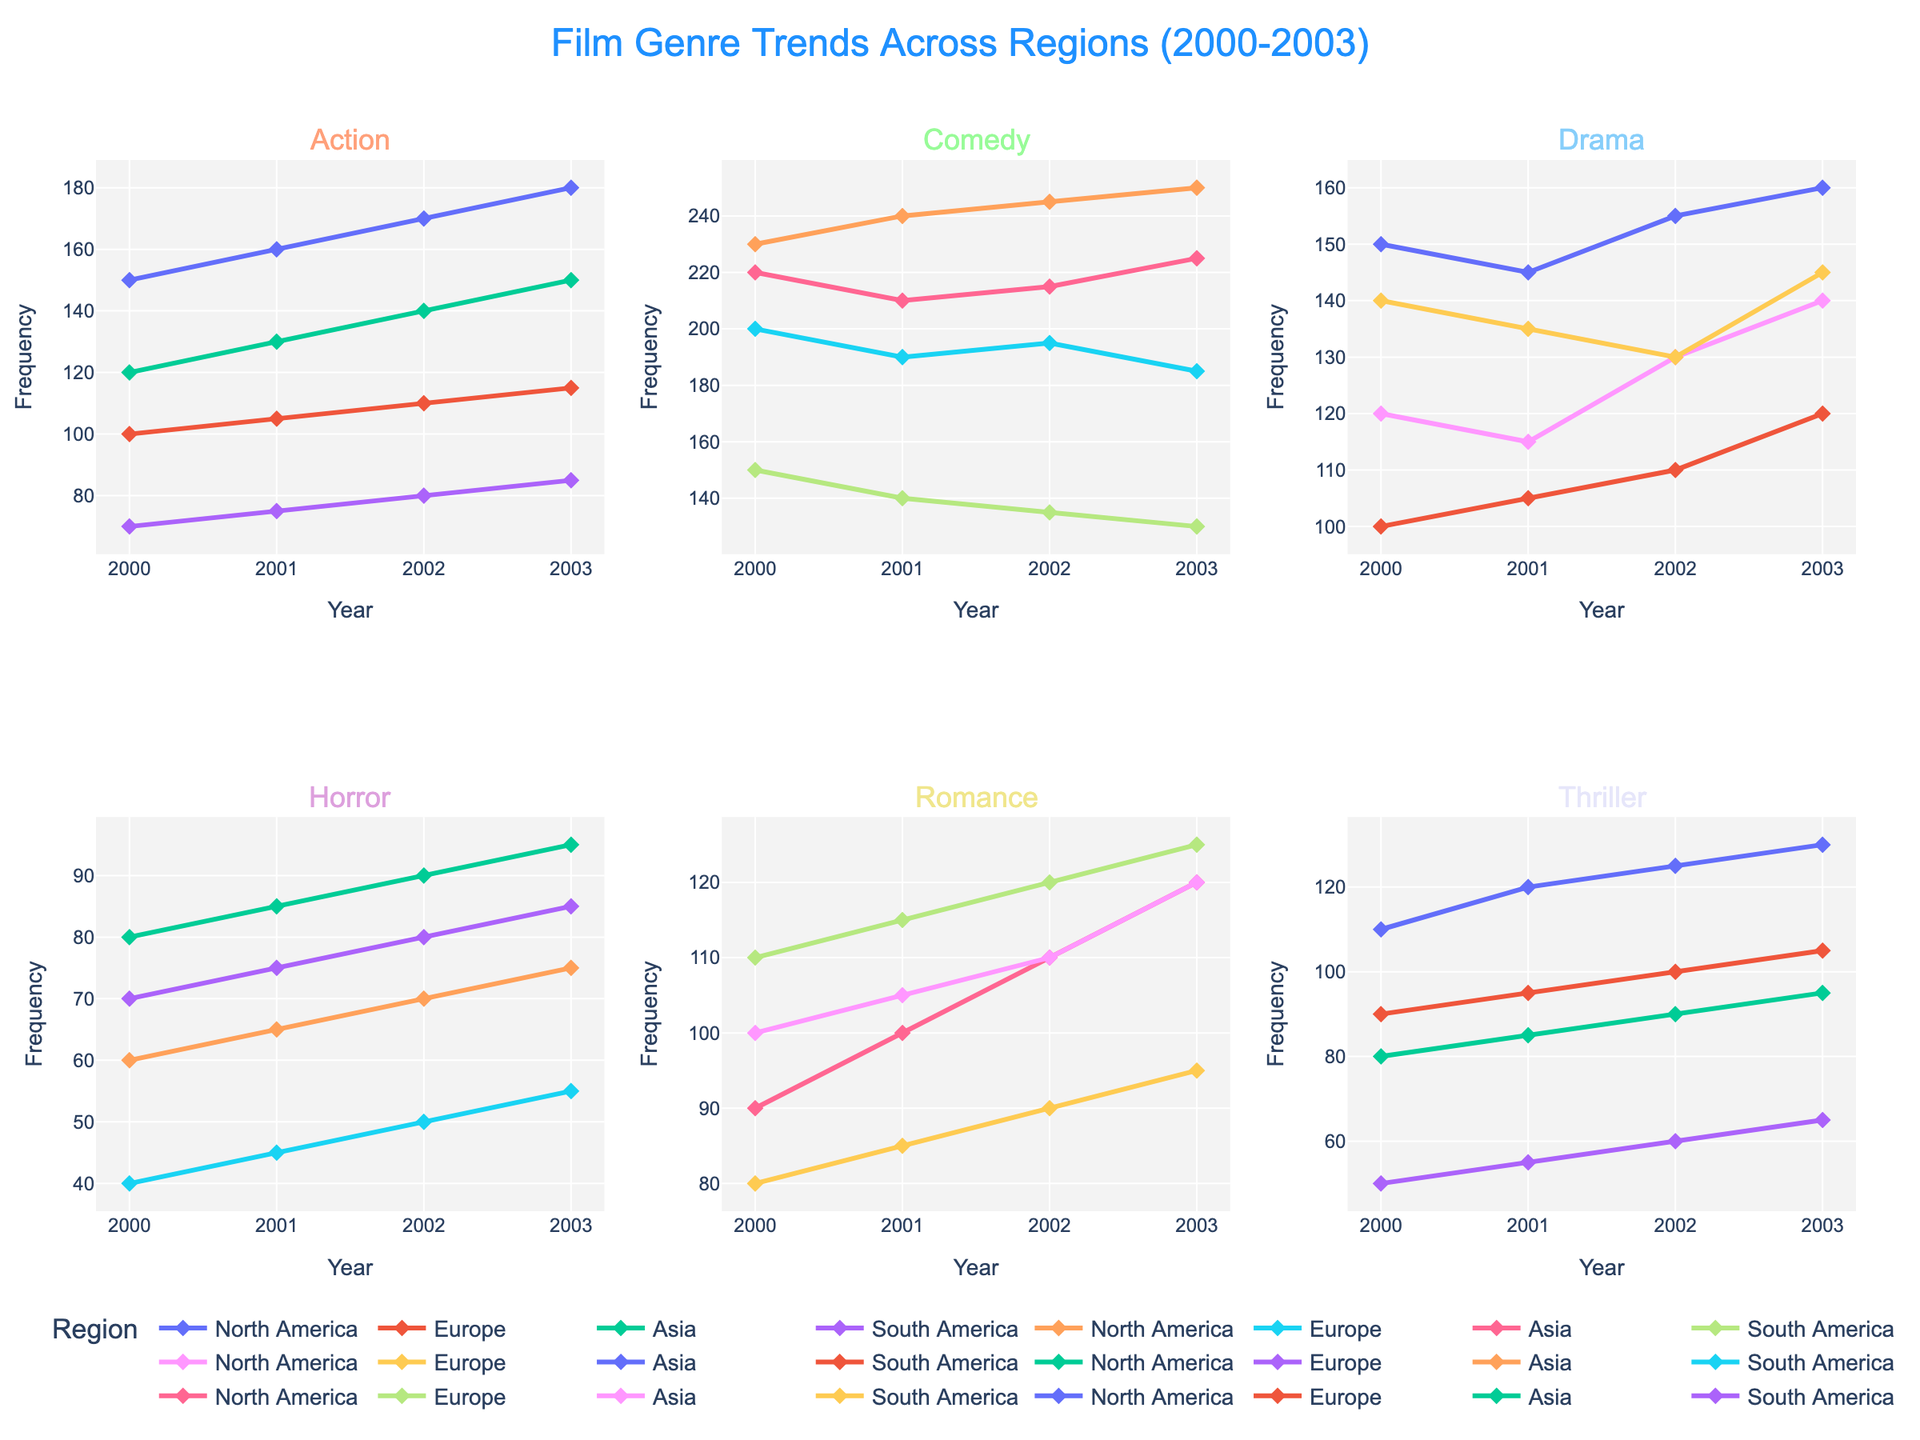Which region had the highest frequency of Action genre in 2003? In the subplot for the Action genre, look at the data points marked for the year 2003 across all regions. The highest point is for North America.
Answer: North America How did the frequency of Comedy genre change in Europe from 2000 to 2003? In the subplot for the Comedy genre, observe the trend line for Europe from 2000 to 2003. The line starts at 200 in 2000 and goes down to 185 in 2003.
Answer: Decreased Which genre had the most noticeable increase in Asia between 2000 and 2003? Comparing the trends in all six subplots for Asia, the Action genre shows a clear upward trend from 120 in 2000 to 150 in 2003.
Answer: Action What is the average frequency of Drama genres in South America across the years? Find the Drama values for South America: 100 (2000), 105 (2001), 110 (2002), and 120 (2003). Calculate the average: (100 + 105 + 110 + 120) / 4 = 108.75.
Answer: 108.75 Which two regions show similar trends for the Horror genre? In the subplot for Horror, observe the lines for all regions. Both Europe and Asia show an increasing trend but fluctuate around similar frequencies.
Answer: Europe and Asia What genre had the smallest variation in North America over the years? Look at the spread of data points for each genre in the North America subplots. Drama frequency varies from 115 to 140, which is relatively small compared to other genres.
Answer: Drama How does the frequency of Romance genres in 2002 compare between Asia and South America? Observe the points for Romance in 2002, where Asia has a frequency of 110 and South America has 90.
Answer: Higher in Asia Which region had the lowest overall frequency for the Thriller genre? Comparing all regions in the Thriller subplot, South America consistently shows the lowest points (between 50 to 65).
Answer: South America Which genre shows the most consistent upward trend in North America? Look at the subplots for North America and observe trends. Action genre shows a consistent increase over the years.
Answer: Action 